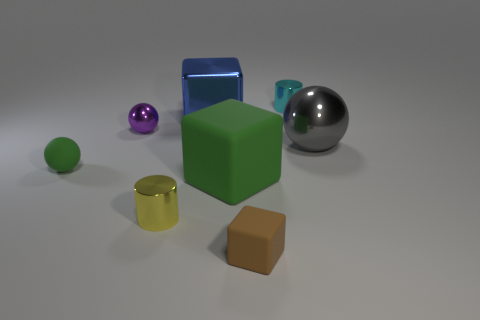Can you tell me about the lighting in this scene? The lighting in the scene appears to be soft and diffused, coming from the upper left, based on the shadows cast by the objects. It provides a gentle illumination that highlights the shape and texture of each item without causing any harsh reflections. 